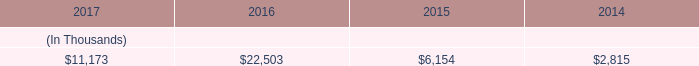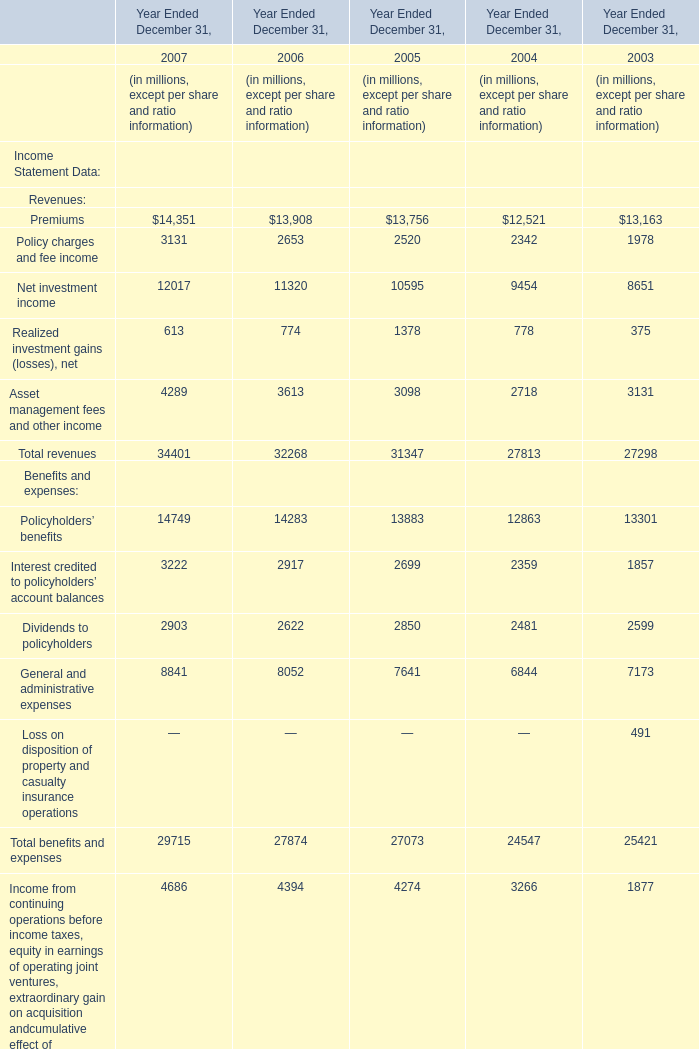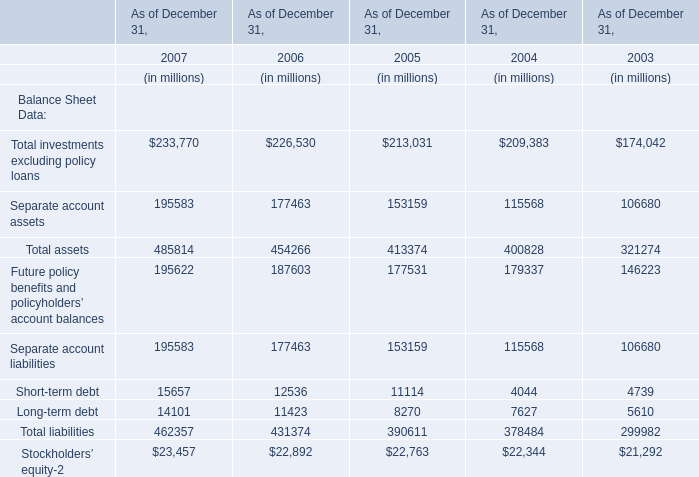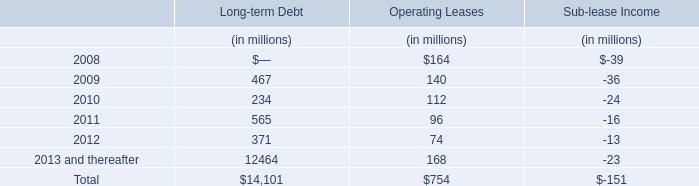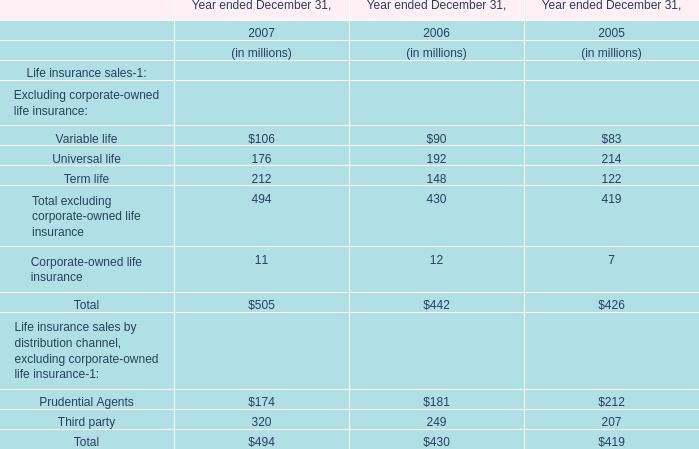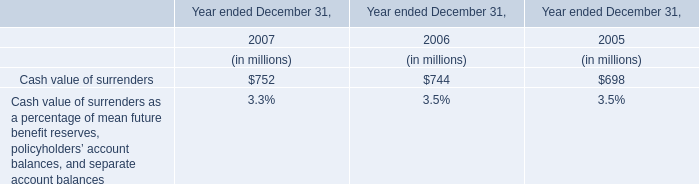What is the sum of As of December 31, in the range of 0 and 20000 in 2005? (in million) 
Computations: (11114 + 8270)
Answer: 19384.0. 